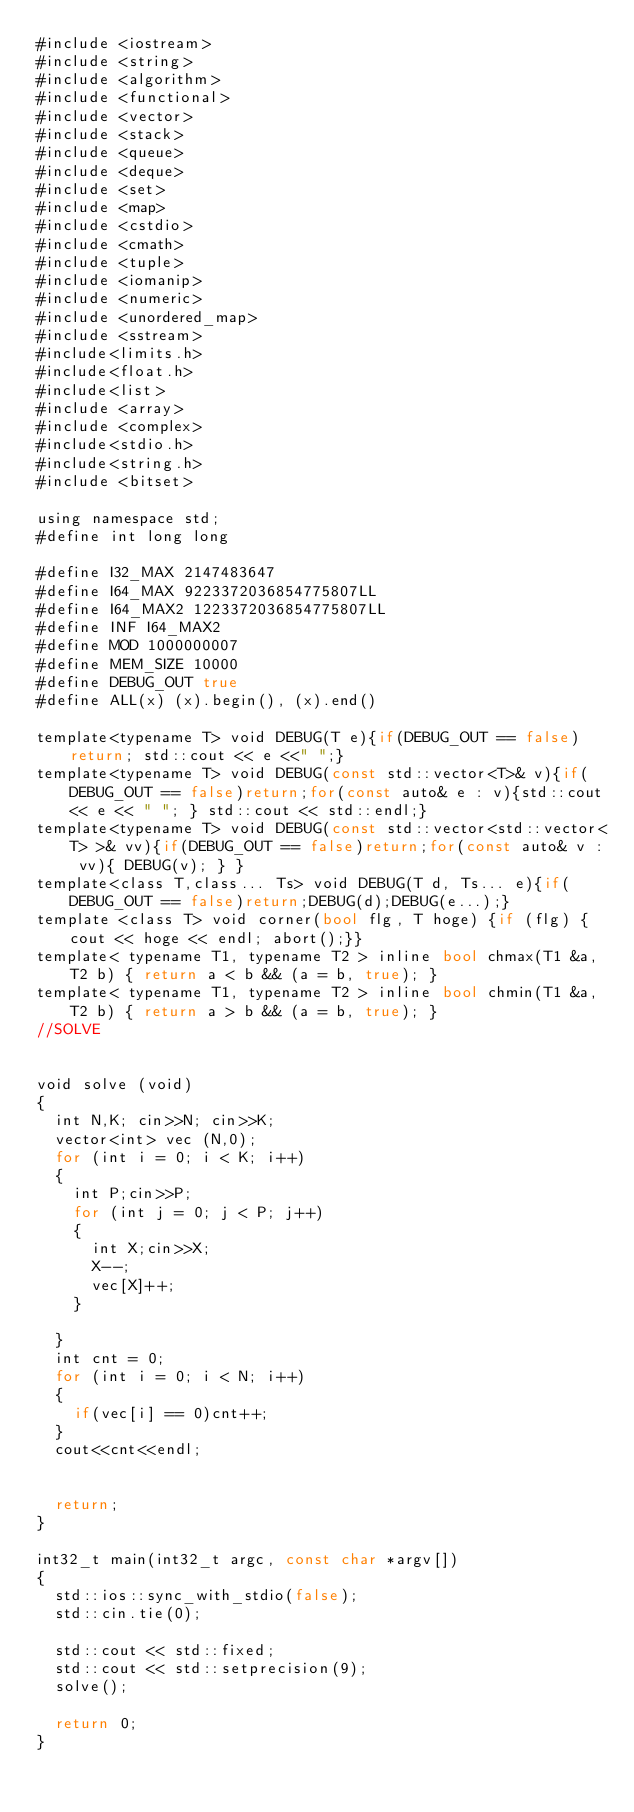<code> <loc_0><loc_0><loc_500><loc_500><_Rust_>#include <iostream>
#include <string>
#include <algorithm>
#include <functional>
#include <vector>
#include <stack>
#include <queue>
#include <deque>
#include <set>
#include <map>
#include <cstdio>
#include <cmath>
#include <tuple>
#include <iomanip>
#include <numeric>
#include <unordered_map>
#include <sstream>
#include<limits.h>
#include<float.h>
#include<list>
#include <array>
#include <complex>
#include<stdio.h>
#include<string.h>
#include <bitset>

using namespace std;
#define int long long

#define I32_MAX 2147483647
#define I64_MAX 9223372036854775807LL
#define I64_MAX2 1223372036854775807LL
#define INF I64_MAX2
#define MOD 1000000007
#define MEM_SIZE 10000
#define DEBUG_OUT true
#define ALL(x) (x).begin(), (x).end()

template<typename T> void DEBUG(T e){if(DEBUG_OUT == false)return; std::cout << e <<" ";}
template<typename T> void DEBUG(const std::vector<T>& v){if(DEBUG_OUT == false)return;for(const auto& e : v){std::cout<< e << " "; } std::cout << std::endl;}
template<typename T> void DEBUG(const std::vector<std::vector<T> >& vv){if(DEBUG_OUT == false)return;for(const auto& v : vv){ DEBUG(v); } }
template<class T,class... Ts> void DEBUG(T d, Ts... e){if(DEBUG_OUT == false)return;DEBUG(d);DEBUG(e...);}
template <class T> void corner(bool flg, T hoge) {if (flg) {cout << hoge << endl; abort();}}
template< typename T1, typename T2 > inline bool chmax(T1 &a, T2 b) { return a < b && (a = b, true); }
template< typename T1, typename T2 > inline bool chmin(T1 &a, T2 b) { return a > b && (a = b, true); }
//SOLVE


void solve (void)
{
  int N,K; cin>>N; cin>>K;
  vector<int> vec (N,0);
  for (int i = 0; i < K; i++)
  {
    int P;cin>>P;
    for (int j = 0; j < P; j++)
    {
      int X;cin>>X;
      X--;
      vec[X]++;
    }
    
  }
  int cnt = 0;
  for (int i = 0; i < N; i++)
  {
    if(vec[i] == 0)cnt++;
  }
  cout<<cnt<<endl;
  
  
  return;
}

int32_t main(int32_t argc, const char *argv[])
{
  std::ios::sync_with_stdio(false);
  std::cin.tie(0);

  std::cout << std::fixed;
  std::cout << std::setprecision(9);
  solve();

  return 0;
}
</code> 